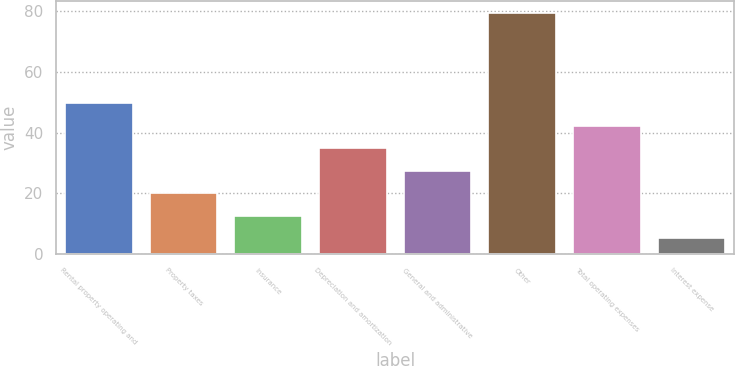Convert chart. <chart><loc_0><loc_0><loc_500><loc_500><bar_chart><fcel>Rental property operating and<fcel>Property taxes<fcel>Insurance<fcel>Depreciation and amortization<fcel>General and administrative<fcel>Other<fcel>Total operating expenses<fcel>Interest expense<nl><fcel>49.74<fcel>19.98<fcel>12.54<fcel>34.86<fcel>27.42<fcel>79.5<fcel>42.3<fcel>5.1<nl></chart> 